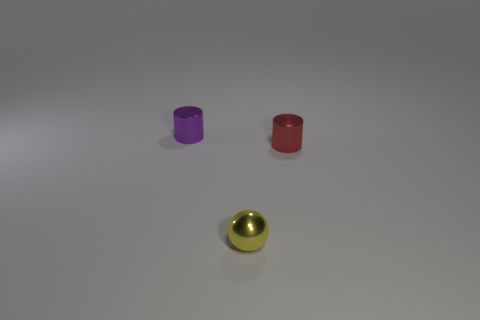Is there a tiny ball?
Make the answer very short. Yes. There is a shiny object that is behind the tiny metallic cylinder right of the tiny purple shiny thing; how big is it?
Ensure brevity in your answer.  Small. Are there any big blocks that have the same material as the tiny red thing?
Offer a very short reply. No. There is a red thing that is the same size as the purple shiny object; what is it made of?
Offer a terse response. Metal. Is the color of the tiny metal cylinder on the left side of the red cylinder the same as the cylinder that is right of the purple shiny cylinder?
Give a very brief answer. No. Are there any tiny red objects on the left side of the metallic cylinder on the left side of the small yellow metal ball?
Your response must be concise. No. Do the tiny thing on the right side of the metallic sphere and the tiny metal object on the left side of the small yellow thing have the same shape?
Your answer should be compact. Yes. Is the cylinder that is in front of the purple shiny cylinder made of the same material as the small object on the left side of the yellow metallic thing?
Your answer should be very brief. Yes. What is the material of the object that is in front of the tiny red shiny thing to the right of the small purple cylinder?
Offer a terse response. Metal. What shape is the small metallic thing on the right side of the metallic thing that is in front of the tiny shiny cylinder in front of the tiny purple shiny object?
Offer a very short reply. Cylinder. 